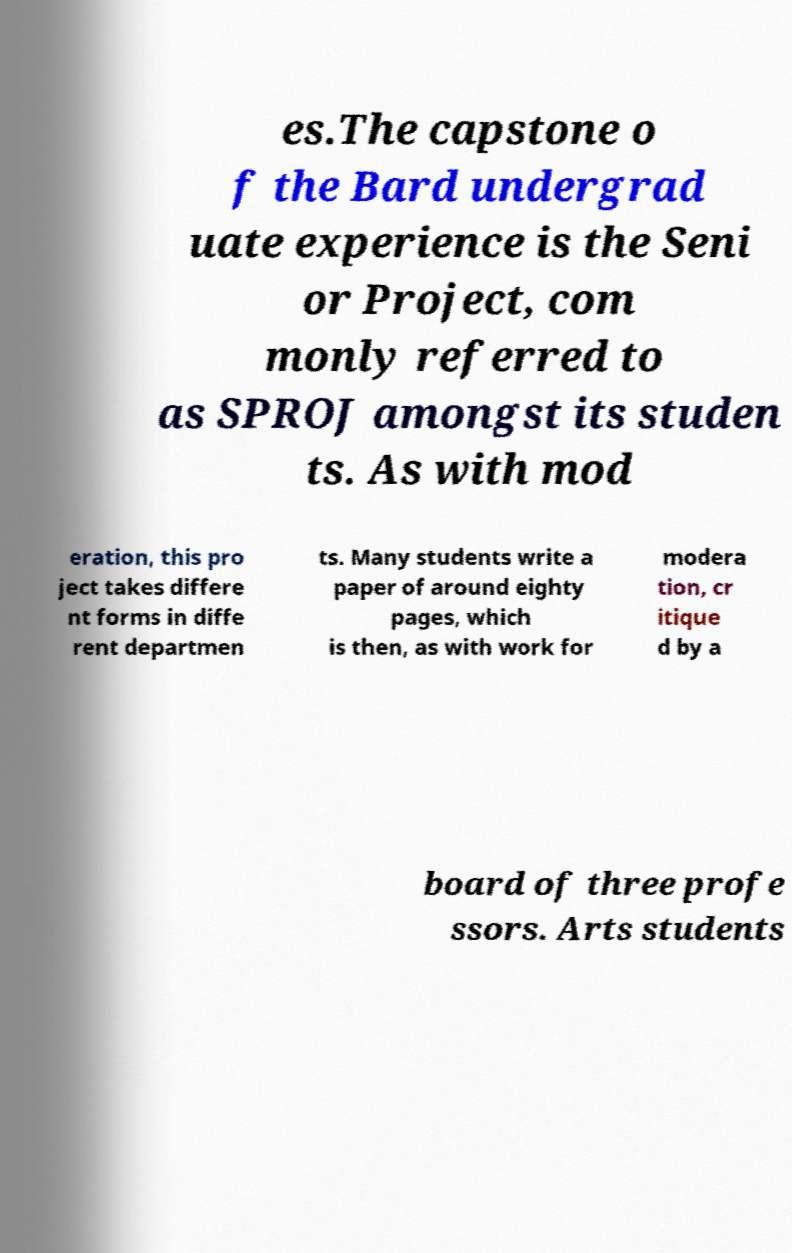Could you assist in decoding the text presented in this image and type it out clearly? es.The capstone o f the Bard undergrad uate experience is the Seni or Project, com monly referred to as SPROJ amongst its studen ts. As with mod eration, this pro ject takes differe nt forms in diffe rent departmen ts. Many students write a paper of around eighty pages, which is then, as with work for modera tion, cr itique d by a board of three profe ssors. Arts students 